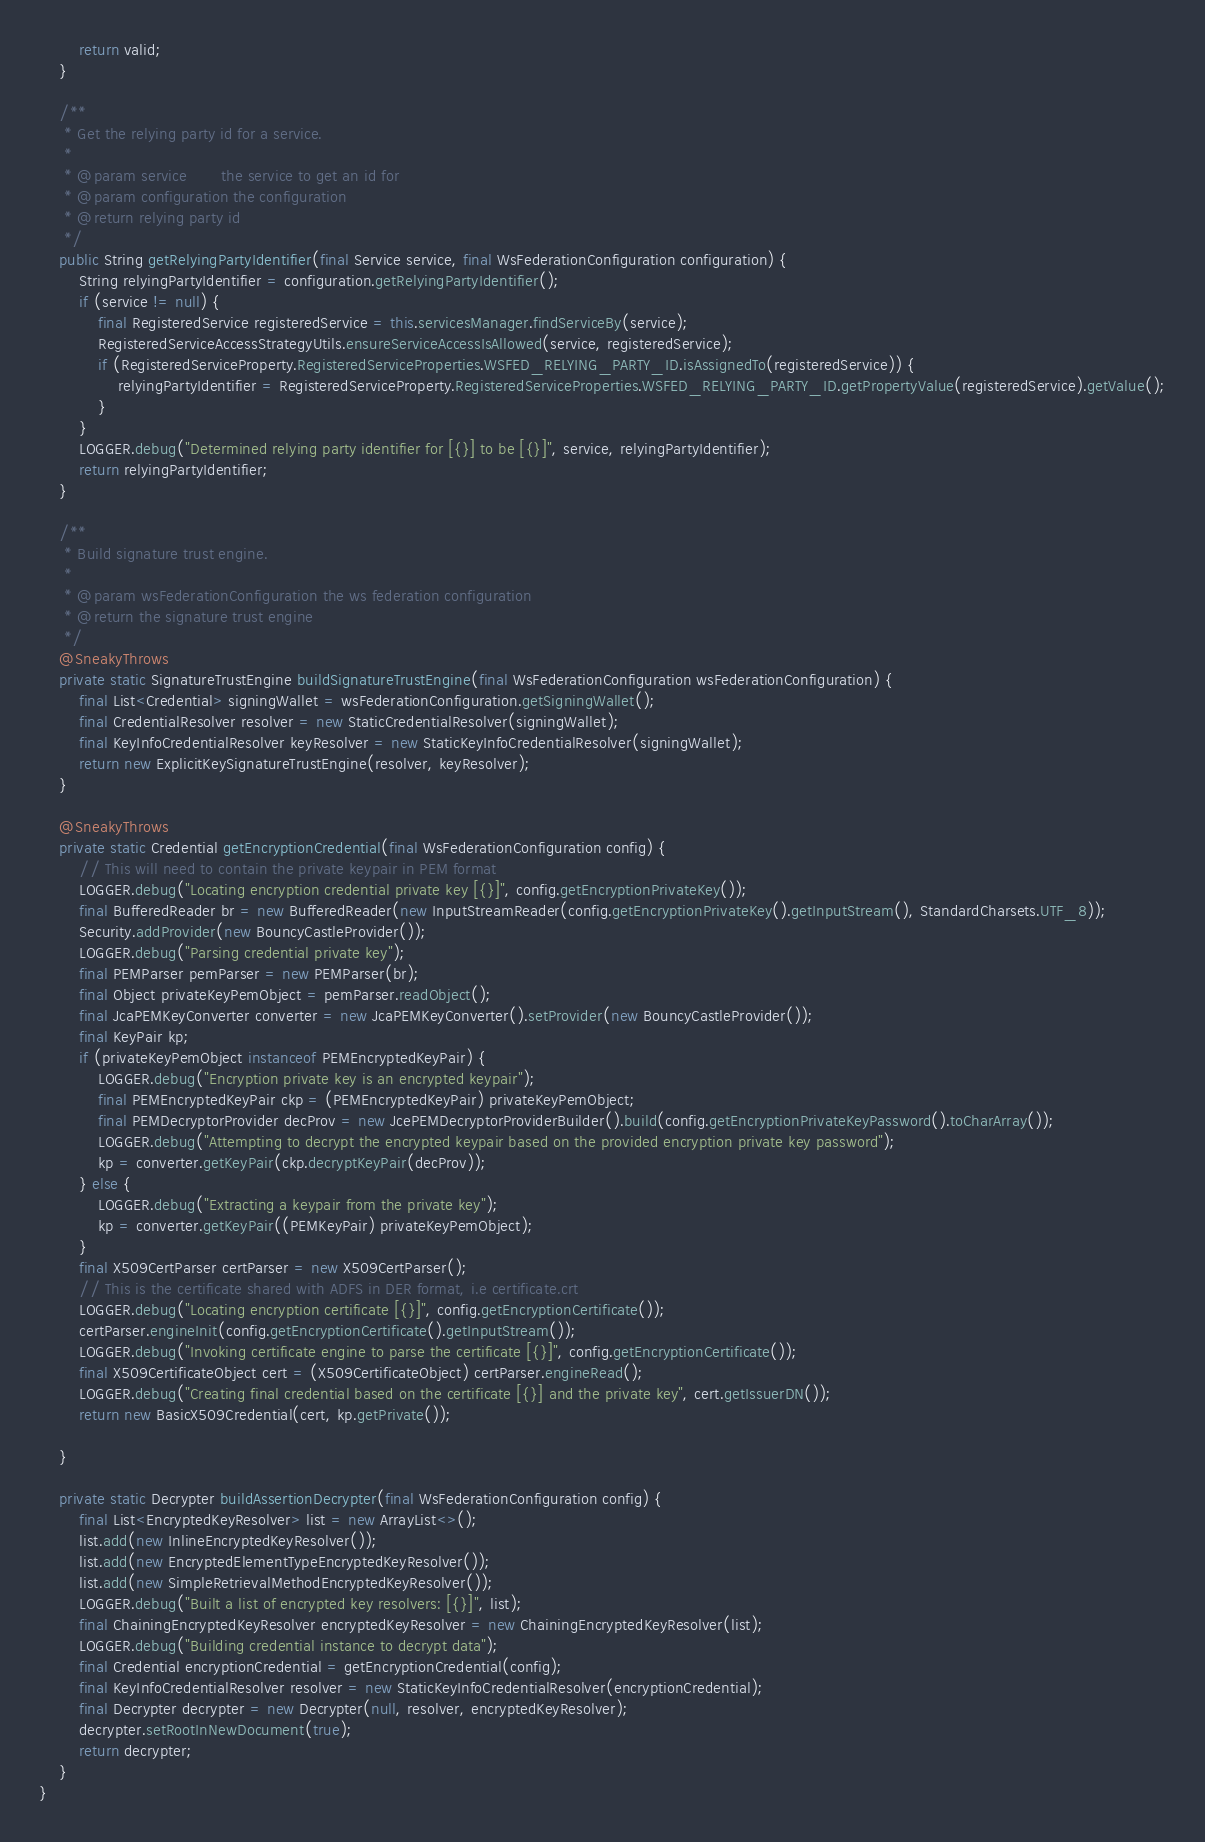<code> <loc_0><loc_0><loc_500><loc_500><_Java_>        return valid;
    }

    /**
     * Get the relying party id for a service.
     *
     * @param service       the service to get an id for
     * @param configuration the configuration
     * @return relying party id
     */
    public String getRelyingPartyIdentifier(final Service service, final WsFederationConfiguration configuration) {
        String relyingPartyIdentifier = configuration.getRelyingPartyIdentifier();
        if (service != null) {
            final RegisteredService registeredService = this.servicesManager.findServiceBy(service);
            RegisteredServiceAccessStrategyUtils.ensureServiceAccessIsAllowed(service, registeredService);
            if (RegisteredServiceProperty.RegisteredServiceProperties.WSFED_RELYING_PARTY_ID.isAssignedTo(registeredService)) {
                relyingPartyIdentifier = RegisteredServiceProperty.RegisteredServiceProperties.WSFED_RELYING_PARTY_ID.getPropertyValue(registeredService).getValue();
            }
        }
        LOGGER.debug("Determined relying party identifier for [{}] to be [{}]", service, relyingPartyIdentifier);
        return relyingPartyIdentifier;
    }

    /**
     * Build signature trust engine.
     *
     * @param wsFederationConfiguration the ws federation configuration
     * @return the signature trust engine
     */
    @SneakyThrows
    private static SignatureTrustEngine buildSignatureTrustEngine(final WsFederationConfiguration wsFederationConfiguration) {
        final List<Credential> signingWallet = wsFederationConfiguration.getSigningWallet();
        final CredentialResolver resolver = new StaticCredentialResolver(signingWallet);
        final KeyInfoCredentialResolver keyResolver = new StaticKeyInfoCredentialResolver(signingWallet);
        return new ExplicitKeySignatureTrustEngine(resolver, keyResolver);
    }

    @SneakyThrows
    private static Credential getEncryptionCredential(final WsFederationConfiguration config) {
        // This will need to contain the private keypair in PEM format
        LOGGER.debug("Locating encryption credential private key [{}]", config.getEncryptionPrivateKey());
        final BufferedReader br = new BufferedReader(new InputStreamReader(config.getEncryptionPrivateKey().getInputStream(), StandardCharsets.UTF_8));
        Security.addProvider(new BouncyCastleProvider());
        LOGGER.debug("Parsing credential private key");
        final PEMParser pemParser = new PEMParser(br);
        final Object privateKeyPemObject = pemParser.readObject();
        final JcaPEMKeyConverter converter = new JcaPEMKeyConverter().setProvider(new BouncyCastleProvider());
        final KeyPair kp;
        if (privateKeyPemObject instanceof PEMEncryptedKeyPair) {
            LOGGER.debug("Encryption private key is an encrypted keypair");
            final PEMEncryptedKeyPair ckp = (PEMEncryptedKeyPair) privateKeyPemObject;
            final PEMDecryptorProvider decProv = new JcePEMDecryptorProviderBuilder().build(config.getEncryptionPrivateKeyPassword().toCharArray());
            LOGGER.debug("Attempting to decrypt the encrypted keypair based on the provided encryption private key password");
            kp = converter.getKeyPair(ckp.decryptKeyPair(decProv));
        } else {
            LOGGER.debug("Extracting a keypair from the private key");
            kp = converter.getKeyPair((PEMKeyPair) privateKeyPemObject);
        }
        final X509CertParser certParser = new X509CertParser();
        // This is the certificate shared with ADFS in DER format, i.e certificate.crt
        LOGGER.debug("Locating encryption certificate [{}]", config.getEncryptionCertificate());
        certParser.engineInit(config.getEncryptionCertificate().getInputStream());
        LOGGER.debug("Invoking certificate engine to parse the certificate [{}]", config.getEncryptionCertificate());
        final X509CertificateObject cert = (X509CertificateObject) certParser.engineRead();
        LOGGER.debug("Creating final credential based on the certificate [{}] and the private key", cert.getIssuerDN());
        return new BasicX509Credential(cert, kp.getPrivate());

    }

    private static Decrypter buildAssertionDecrypter(final WsFederationConfiguration config) {
        final List<EncryptedKeyResolver> list = new ArrayList<>();
        list.add(new InlineEncryptedKeyResolver());
        list.add(new EncryptedElementTypeEncryptedKeyResolver());
        list.add(new SimpleRetrievalMethodEncryptedKeyResolver());
        LOGGER.debug("Built a list of encrypted key resolvers: [{}]", list);
        final ChainingEncryptedKeyResolver encryptedKeyResolver = new ChainingEncryptedKeyResolver(list);
        LOGGER.debug("Building credential instance to decrypt data");
        final Credential encryptionCredential = getEncryptionCredential(config);
        final KeyInfoCredentialResolver resolver = new StaticKeyInfoCredentialResolver(encryptionCredential);
        final Decrypter decrypter = new Decrypter(null, resolver, encryptedKeyResolver);
        decrypter.setRootInNewDocument(true);
        return decrypter;
    }
}
</code> 